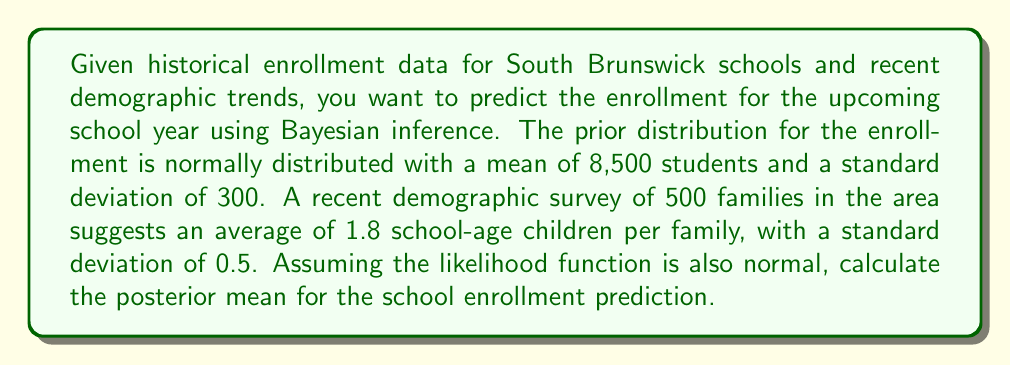Show me your answer to this math problem. To solve this problem, we'll use Bayesian updating with conjugate priors. Since both the prior and likelihood are normally distributed, the posterior will also be normal.

Let's define our variables:
$\mu_0 = 8500$ (prior mean)
$\sigma_0 = 300$ (prior standard deviation)
$\bar{x} = 1.8 \times 500 = 900$ (sample mean, scaled to total students)
$\sigma = 0.5 \times \sqrt{500} \approx 11.18$ (sample standard deviation, scaled to total students)
$n = 1$ (we treat the survey as one observation of the total student population)

The formula for the posterior mean in this case is:

$$\mu_n = \frac{\frac{\mu_0}{\sigma_0^2} + \frac{n\bar{x}}{\sigma^2}}{\frac{1}{\sigma_0^2} + \frac{n}{\sigma^2}}$$

Let's substitute our values:

$$\mu_n = \frac{\frac{8500}{300^2} + \frac{1 \times 900}{11.18^2}}{\frac{1}{300^2} + \frac{1}{11.18^2}}$$

Simplifying:

$$\mu_n = \frac{\frac{8500}{90000} + \frac{900}{124.9924}}{\frac{1}{90000} + \frac{1}{124.9924}}$$

$$\mu_n = \frac{0.0944 + 7.2004}{0.0000111 + 0.0080}$$

$$\mu_n = \frac{7.2948}{0.0080111} \approx 910.59$$

Therefore, the posterior mean for the school enrollment prediction is approximately 911 students (rounded to the nearest whole number).
Answer: 911 students 